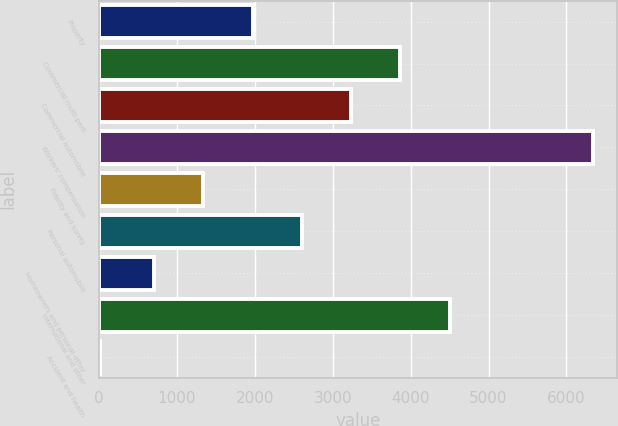<chart> <loc_0><loc_0><loc_500><loc_500><bar_chart><fcel>Property<fcel>Commercial multi-peril<fcel>Commercial automobile<fcel>Workers' compensation<fcel>Fidelity and surety<fcel>Personal automobile<fcel>Homeowners and personal-other<fcel>International and other<fcel>Accident and health<nl><fcel>1971.4<fcel>3869.5<fcel>3236.8<fcel>6337<fcel>1338.7<fcel>2604.1<fcel>706<fcel>4502.2<fcel>10<nl></chart> 